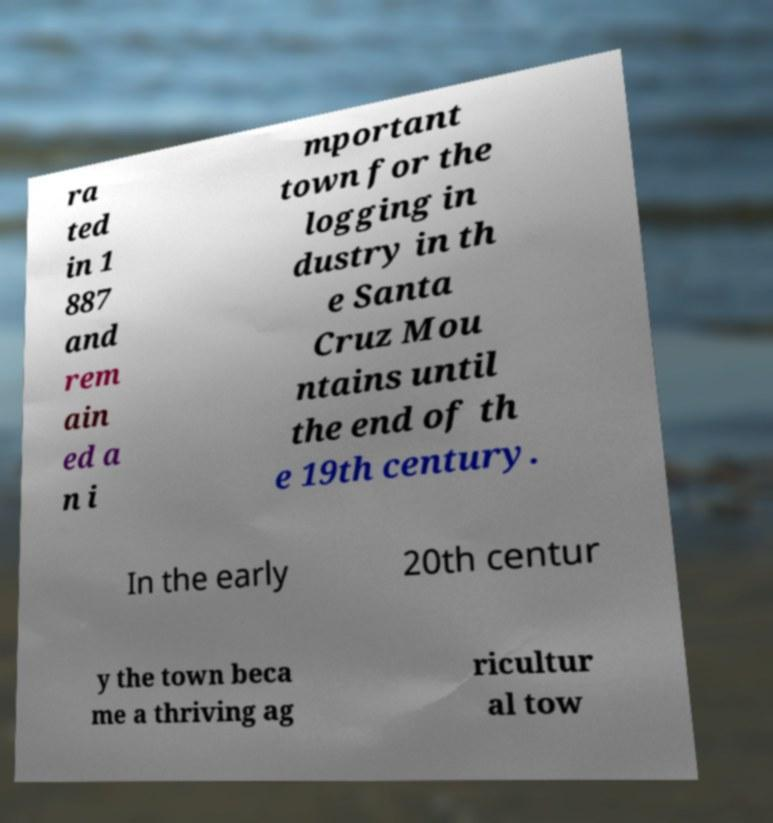Can you read and provide the text displayed in the image?This photo seems to have some interesting text. Can you extract and type it out for me? ra ted in 1 887 and rem ain ed a n i mportant town for the logging in dustry in th e Santa Cruz Mou ntains until the end of th e 19th century. In the early 20th centur y the town beca me a thriving ag ricultur al tow 